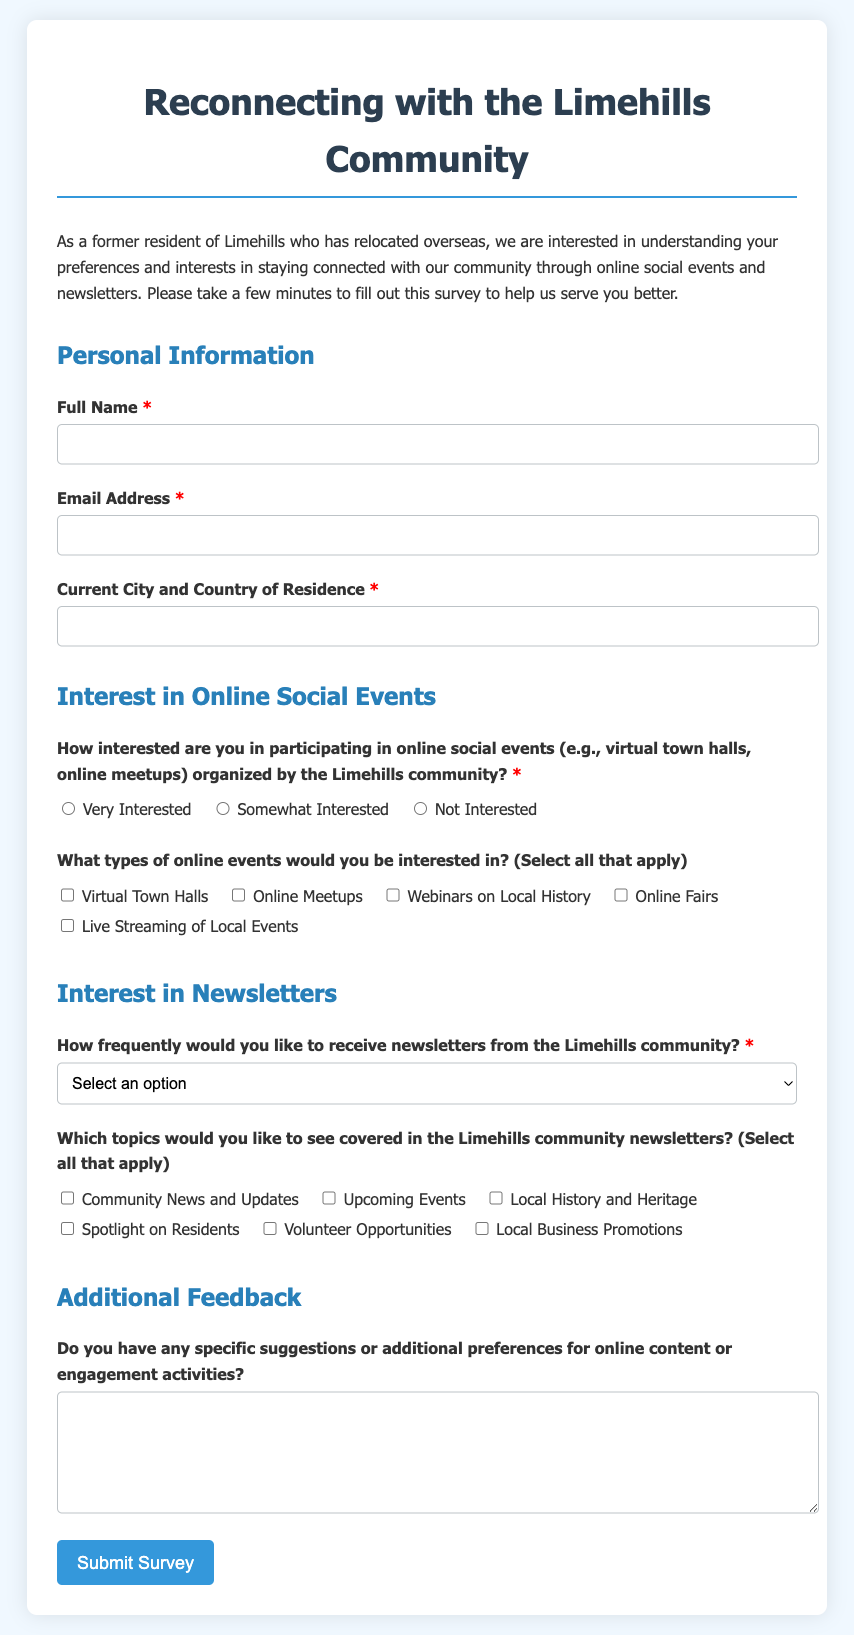What is the title of the document? The title of the document is indicated at the top of the rendered form.
Answer: Reconnecting with the Limehills Community What are the required fields in the personal information section? The required fields are mentioned with the class "required" in the personal information section.
Answer: Full Name, Email Address, Current City and Country of Residence How often can you choose to receive newsletters? The options for newsletter frequency can be found in the dropdown menu within the document.
Answer: Weekly, Bi-weekly, Monthly, Quarterly What is the first type of online event listed for interest selection? The types of online events are listed with checkboxes, starting from the top.
Answer: Virtual Town Halls What additional feedback can the respondents provide? The section for additional feedback allows participants to express their thoughts or suggestions.
Answer: Specific suggestions or additional preferences for online content or engagement activities How many online event types can respondents select? The number of event types is indicated by the number of checkboxes available in that section.
Answer: Five types What is the color scheme of the document? The color scheme is described in the style section and across the various elements of the document.
Answer: Light blue background with white container and blue headings What is the maximum width of the document content? The document mentions a maximum width in its styling for layout purposes.
Answer: 800 pixels What button appears at the bottom of the form? The form has a button meant for submission, indicated by its label.
Answer: Submit Survey 